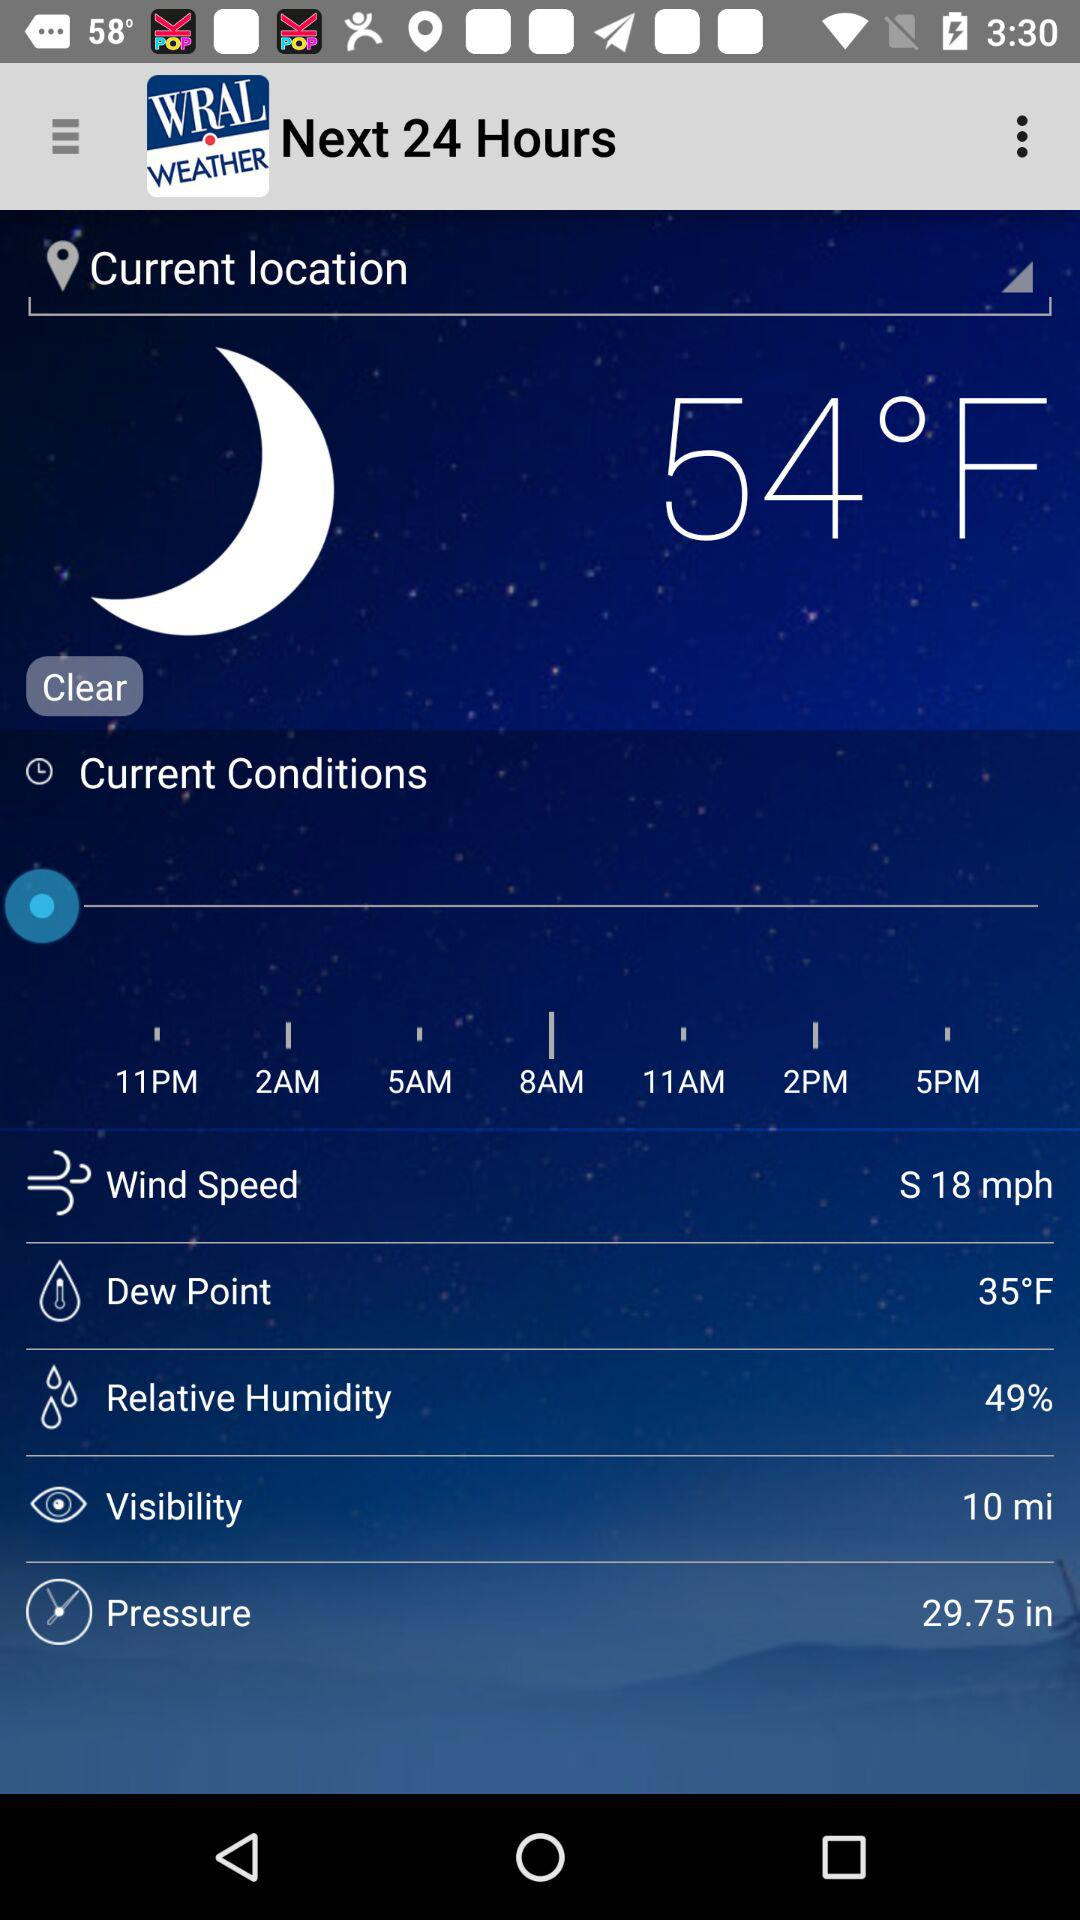How much is the value of dew point? The value of dew point is 35°F. 